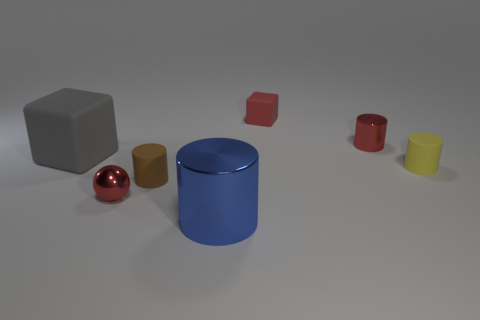Add 2 tiny matte objects. How many objects exist? 9 Subtract all cylinders. How many objects are left? 3 Subtract all gray matte cubes. Subtract all brown objects. How many objects are left? 5 Add 5 red spheres. How many red spheres are left? 6 Add 4 rubber things. How many rubber things exist? 8 Subtract 0 cyan blocks. How many objects are left? 7 